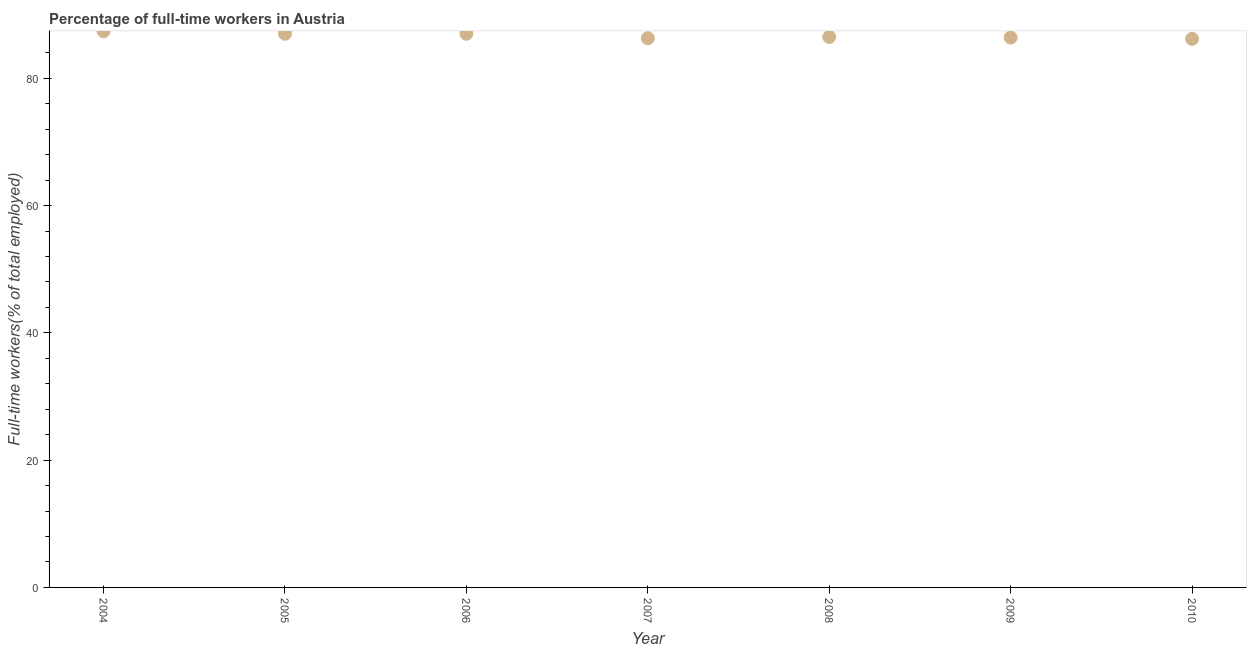What is the percentage of full-time workers in 2010?
Provide a succinct answer. 86.2. Across all years, what is the maximum percentage of full-time workers?
Make the answer very short. 87.4. Across all years, what is the minimum percentage of full-time workers?
Provide a succinct answer. 86.2. What is the sum of the percentage of full-time workers?
Give a very brief answer. 606.8. What is the difference between the percentage of full-time workers in 2006 and 2010?
Offer a terse response. 0.8. What is the average percentage of full-time workers per year?
Your answer should be very brief. 86.69. What is the median percentage of full-time workers?
Offer a very short reply. 86.5. Do a majority of the years between 2007 and 2010 (inclusive) have percentage of full-time workers greater than 44 %?
Give a very brief answer. Yes. What is the ratio of the percentage of full-time workers in 2004 to that in 2007?
Offer a very short reply. 1.01. Is the difference between the percentage of full-time workers in 2005 and 2010 greater than the difference between any two years?
Offer a very short reply. No. What is the difference between the highest and the second highest percentage of full-time workers?
Your response must be concise. 0.4. What is the difference between the highest and the lowest percentage of full-time workers?
Your answer should be compact. 1.2. Does the percentage of full-time workers monotonically increase over the years?
Your response must be concise. No. What is the difference between two consecutive major ticks on the Y-axis?
Offer a terse response. 20. Does the graph contain any zero values?
Provide a succinct answer. No. What is the title of the graph?
Provide a short and direct response. Percentage of full-time workers in Austria. What is the label or title of the Y-axis?
Your answer should be very brief. Full-time workers(% of total employed). What is the Full-time workers(% of total employed) in 2004?
Keep it short and to the point. 87.4. What is the Full-time workers(% of total employed) in 2005?
Ensure brevity in your answer.  87. What is the Full-time workers(% of total employed) in 2007?
Make the answer very short. 86.3. What is the Full-time workers(% of total employed) in 2008?
Provide a succinct answer. 86.5. What is the Full-time workers(% of total employed) in 2009?
Your answer should be very brief. 86.4. What is the Full-time workers(% of total employed) in 2010?
Offer a very short reply. 86.2. What is the difference between the Full-time workers(% of total employed) in 2004 and 2005?
Your response must be concise. 0.4. What is the difference between the Full-time workers(% of total employed) in 2004 and 2009?
Give a very brief answer. 1. What is the difference between the Full-time workers(% of total employed) in 2004 and 2010?
Your response must be concise. 1.2. What is the difference between the Full-time workers(% of total employed) in 2005 and 2009?
Provide a short and direct response. 0.6. What is the difference between the Full-time workers(% of total employed) in 2006 and 2007?
Your answer should be very brief. 0.7. What is the difference between the Full-time workers(% of total employed) in 2006 and 2008?
Provide a succinct answer. 0.5. What is the difference between the Full-time workers(% of total employed) in 2006 and 2010?
Offer a terse response. 0.8. What is the difference between the Full-time workers(% of total employed) in 2007 and 2008?
Ensure brevity in your answer.  -0.2. What is the difference between the Full-time workers(% of total employed) in 2007 and 2010?
Make the answer very short. 0.1. What is the difference between the Full-time workers(% of total employed) in 2008 and 2009?
Give a very brief answer. 0.1. What is the difference between the Full-time workers(% of total employed) in 2008 and 2010?
Provide a short and direct response. 0.3. What is the difference between the Full-time workers(% of total employed) in 2009 and 2010?
Make the answer very short. 0.2. What is the ratio of the Full-time workers(% of total employed) in 2004 to that in 2010?
Ensure brevity in your answer.  1.01. What is the ratio of the Full-time workers(% of total employed) in 2005 to that in 2007?
Offer a terse response. 1.01. What is the ratio of the Full-time workers(% of total employed) in 2005 to that in 2008?
Give a very brief answer. 1.01. What is the ratio of the Full-time workers(% of total employed) in 2005 to that in 2009?
Provide a short and direct response. 1.01. What is the ratio of the Full-time workers(% of total employed) in 2005 to that in 2010?
Your answer should be compact. 1.01. What is the ratio of the Full-time workers(% of total employed) in 2006 to that in 2008?
Your answer should be compact. 1.01. What is the ratio of the Full-time workers(% of total employed) in 2006 to that in 2009?
Your answer should be very brief. 1.01. What is the ratio of the Full-time workers(% of total employed) in 2007 to that in 2009?
Make the answer very short. 1. What is the ratio of the Full-time workers(% of total employed) in 2007 to that in 2010?
Your response must be concise. 1. What is the ratio of the Full-time workers(% of total employed) in 2008 to that in 2009?
Provide a succinct answer. 1. What is the ratio of the Full-time workers(% of total employed) in 2009 to that in 2010?
Offer a very short reply. 1. 